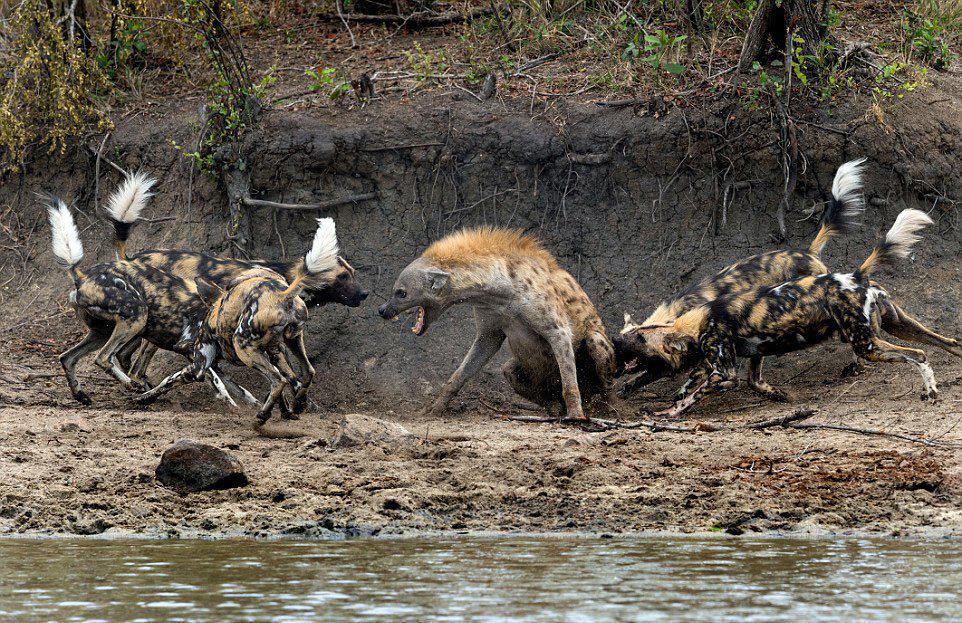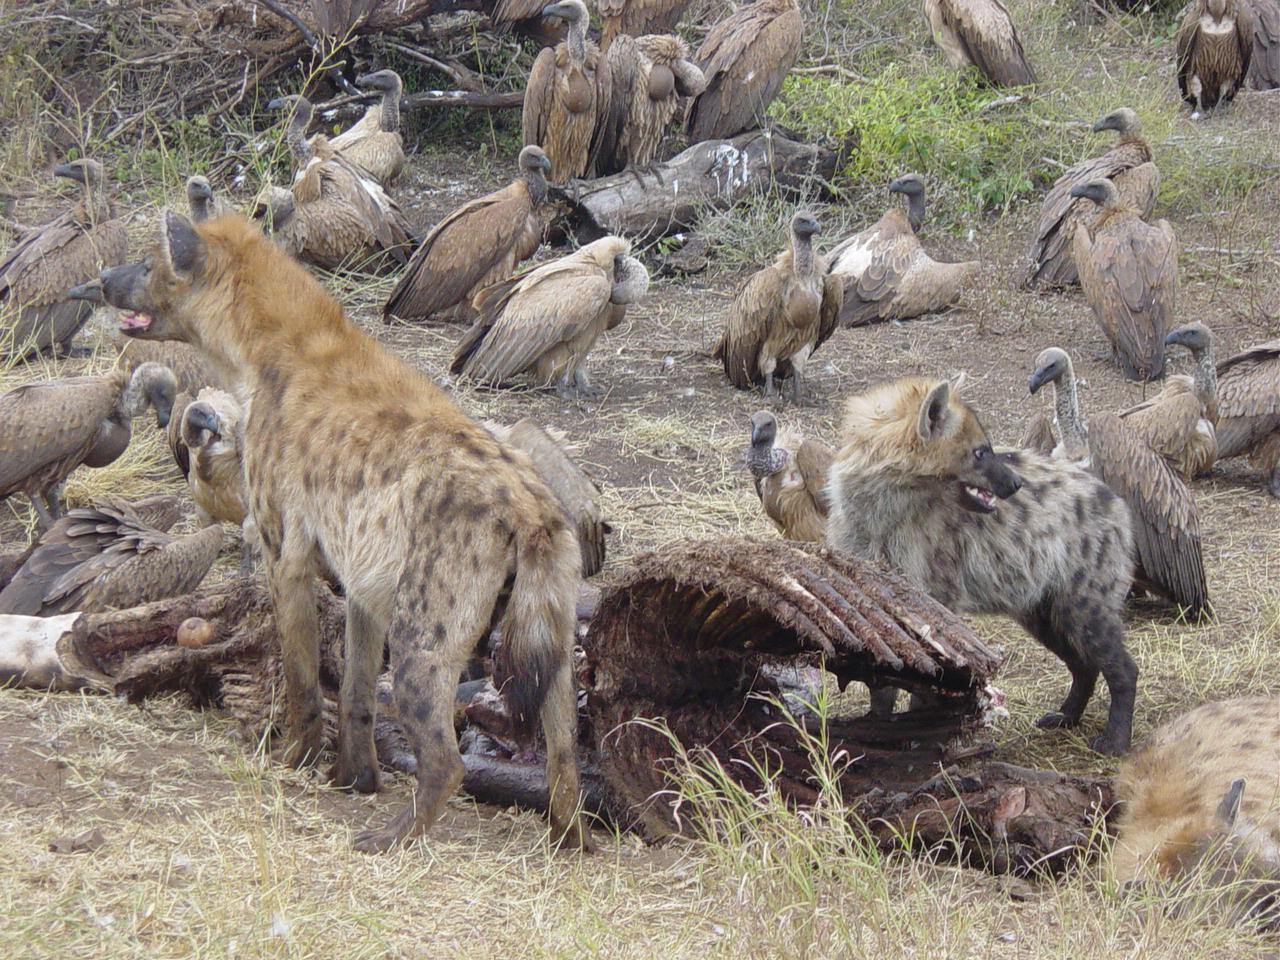The first image is the image on the left, the second image is the image on the right. Evaluate the accuracy of this statement regarding the images: "An image shows different scavenger animals, including hyena, around a carcass.". Is it true? Answer yes or no. Yes. The first image is the image on the left, the second image is the image on the right. Analyze the images presented: Is the assertion "Hyenas are by a body of water." valid? Answer yes or no. Yes. 